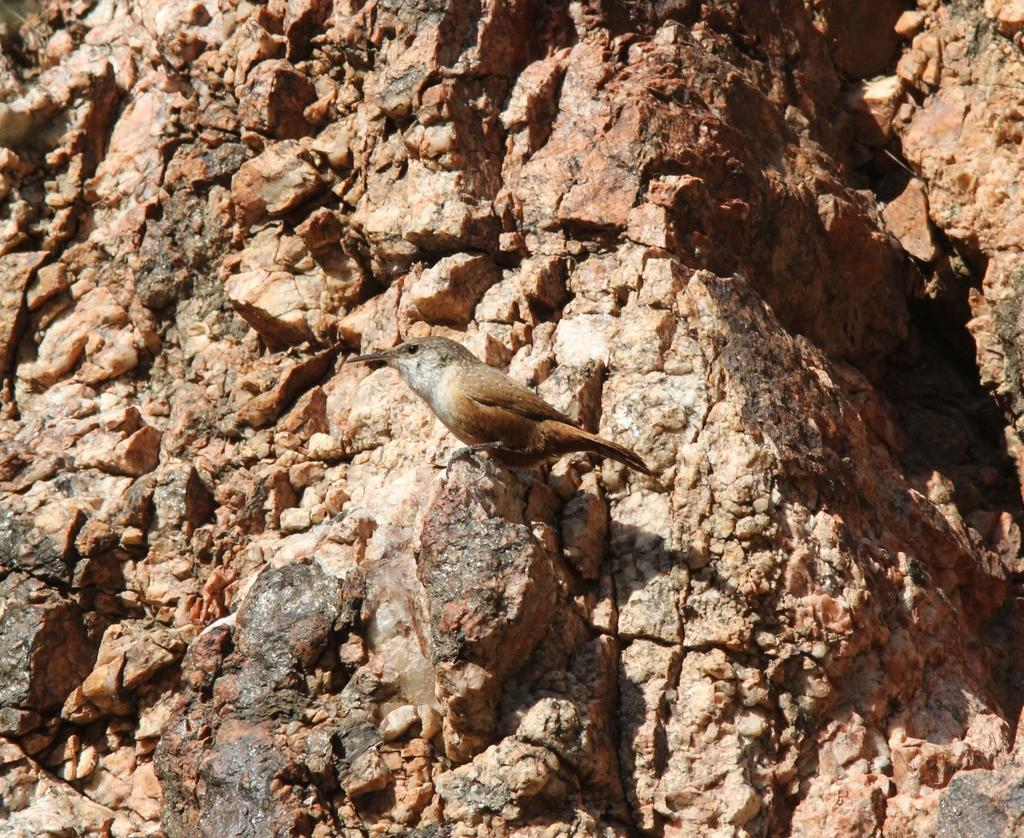What type of animal can be seen in the image? There is a bird in the image. What other object is present in the image? There is a rock in the image. Can you hear the ghost in the image? There is no ghost present in the image, so it is not possible to hear one. 